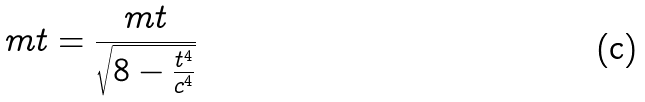<formula> <loc_0><loc_0><loc_500><loc_500>m t = \frac { m t } { \sqrt { 8 - \frac { t ^ { 4 } } { c ^ { 4 } } } }</formula> 